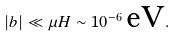Convert formula to latex. <formula><loc_0><loc_0><loc_500><loc_500>| b | \ll \mu H \sim 1 0 ^ { - 6 } \, \text {eV} .</formula> 